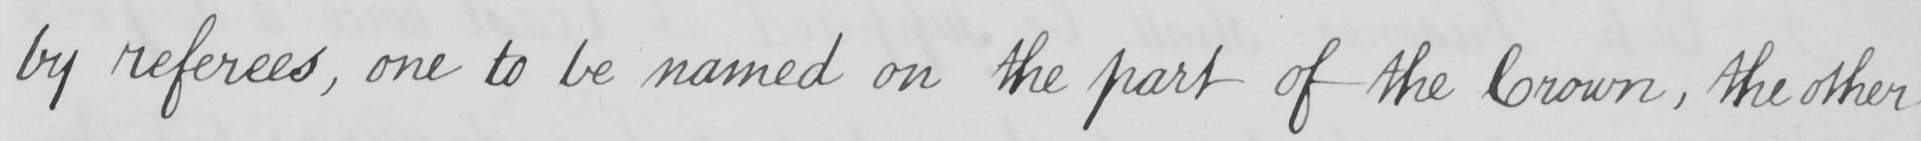Please provide the text content of this handwritten line. by referees , one to be named on the part of the Crown , the other 